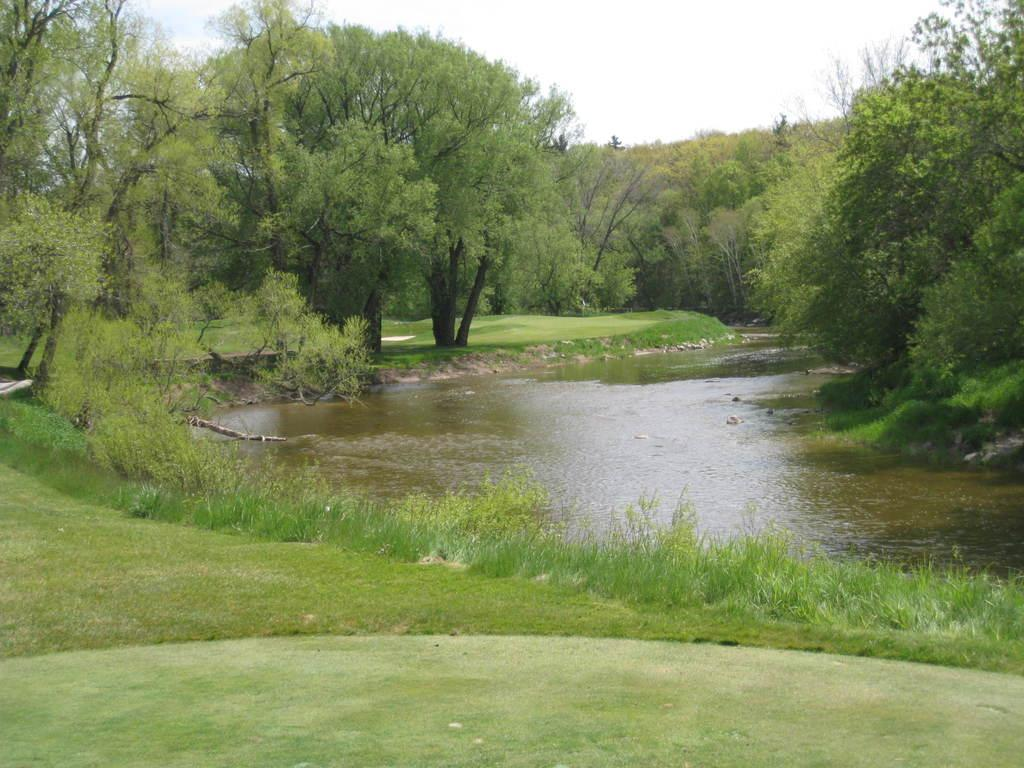What type of surface is visible in the image? There is a greenery ground in the image. What is located in front of the ground? There is water in front of the ground. What can be seen on either side of the ground? There are trees on either side of the ground. What type of nail is being used for teaching in the image? There is no nail or teaching activity present in the image. What type of metal is visible in the image? There is no metal visible in the image. 